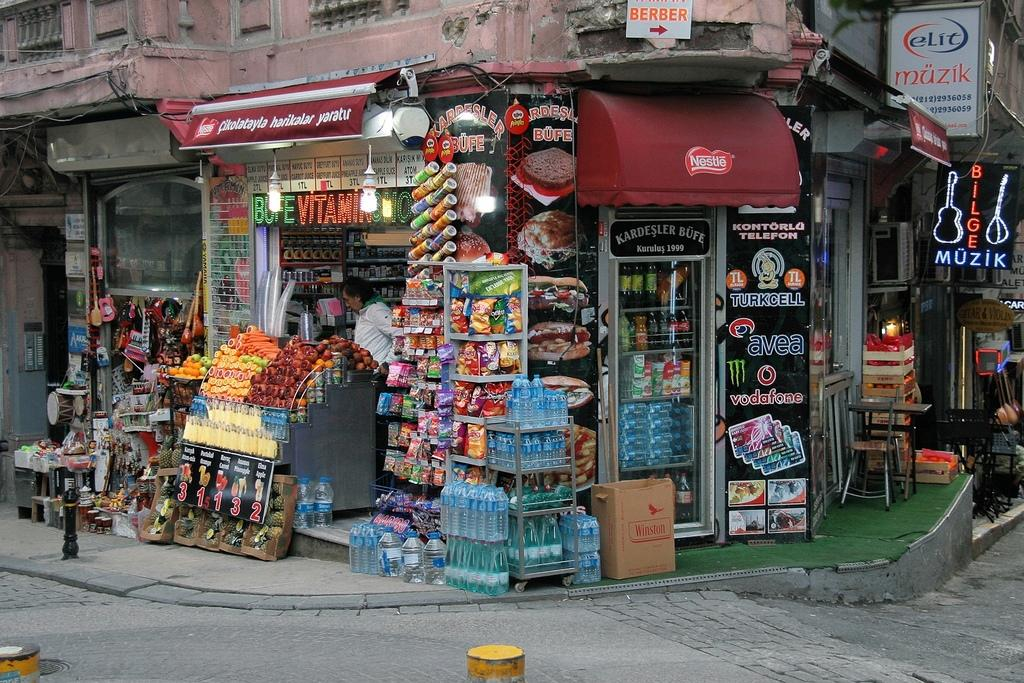<image>
Write a terse but informative summary of the picture. A corner store that advertises muzik with a blur neon sign. 